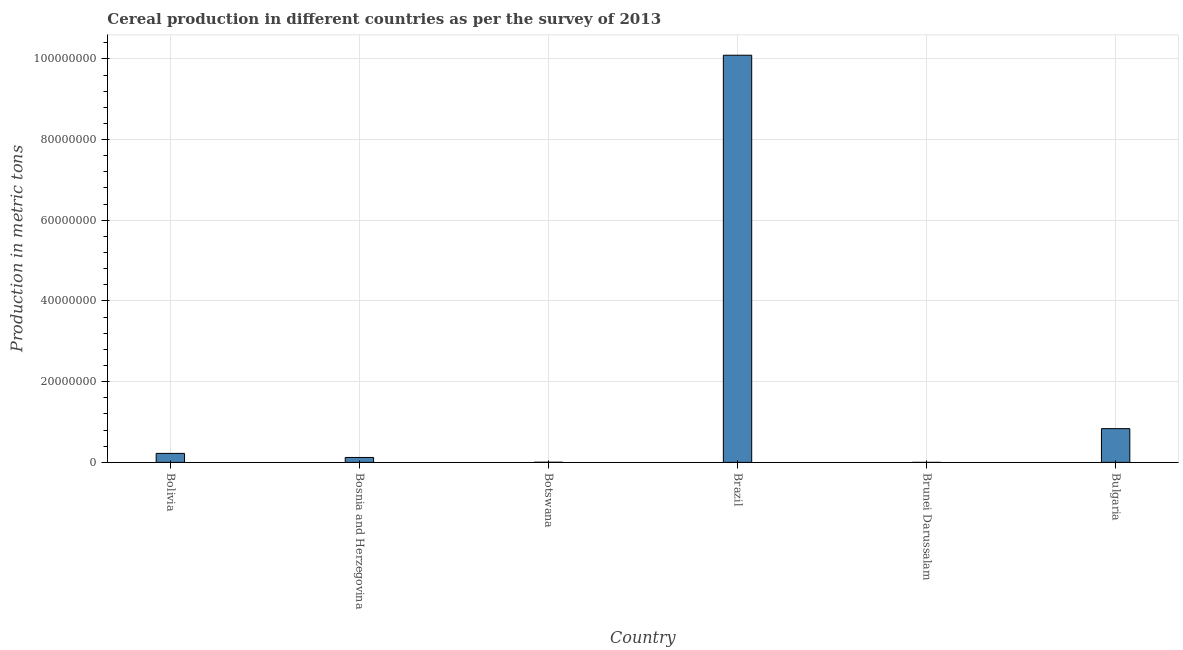Does the graph contain any zero values?
Your answer should be compact. No. What is the title of the graph?
Your answer should be very brief. Cereal production in different countries as per the survey of 2013. What is the label or title of the X-axis?
Provide a succinct answer. Country. What is the label or title of the Y-axis?
Make the answer very short. Production in metric tons. What is the cereal production in Bosnia and Herzegovina?
Make the answer very short. 1.22e+06. Across all countries, what is the maximum cereal production?
Your answer should be very brief. 1.01e+08. Across all countries, what is the minimum cereal production?
Provide a short and direct response. 1850. In which country was the cereal production minimum?
Provide a short and direct response. Brunei Darussalam. What is the sum of the cereal production?
Make the answer very short. 1.13e+08. What is the difference between the cereal production in Botswana and Brunei Darussalam?
Provide a succinct answer. 4.20e+04. What is the average cereal production per country?
Your response must be concise. 1.88e+07. What is the median cereal production?
Your answer should be very brief. 1.73e+06. What is the ratio of the cereal production in Bolivia to that in Bosnia and Herzegovina?
Offer a terse response. 1.82. Is the difference between the cereal production in Brazil and Bulgaria greater than the difference between any two countries?
Ensure brevity in your answer.  No. What is the difference between the highest and the second highest cereal production?
Give a very brief answer. 9.25e+07. Is the sum of the cereal production in Brunei Darussalam and Bulgaria greater than the maximum cereal production across all countries?
Offer a terse response. No. What is the difference between the highest and the lowest cereal production?
Make the answer very short. 1.01e+08. How many countries are there in the graph?
Give a very brief answer. 6. Are the values on the major ticks of Y-axis written in scientific E-notation?
Your response must be concise. No. What is the Production in metric tons of Bolivia?
Offer a very short reply. 2.23e+06. What is the Production in metric tons of Bosnia and Herzegovina?
Offer a terse response. 1.22e+06. What is the Production in metric tons of Botswana?
Offer a terse response. 4.38e+04. What is the Production in metric tons of Brazil?
Your answer should be compact. 1.01e+08. What is the Production in metric tons of Brunei Darussalam?
Provide a short and direct response. 1850. What is the Production in metric tons of Bulgaria?
Your answer should be compact. 8.36e+06. What is the difference between the Production in metric tons in Bolivia and Bosnia and Herzegovina?
Give a very brief answer. 1.01e+06. What is the difference between the Production in metric tons in Bolivia and Botswana?
Provide a short and direct response. 2.19e+06. What is the difference between the Production in metric tons in Bolivia and Brazil?
Ensure brevity in your answer.  -9.87e+07. What is the difference between the Production in metric tons in Bolivia and Brunei Darussalam?
Your answer should be compact. 2.23e+06. What is the difference between the Production in metric tons in Bolivia and Bulgaria?
Offer a very short reply. -6.13e+06. What is the difference between the Production in metric tons in Bosnia and Herzegovina and Botswana?
Offer a very short reply. 1.18e+06. What is the difference between the Production in metric tons in Bosnia and Herzegovina and Brazil?
Your response must be concise. -9.97e+07. What is the difference between the Production in metric tons in Bosnia and Herzegovina and Brunei Darussalam?
Provide a succinct answer. 1.22e+06. What is the difference between the Production in metric tons in Bosnia and Herzegovina and Bulgaria?
Give a very brief answer. -7.14e+06. What is the difference between the Production in metric tons in Botswana and Brazil?
Your answer should be compact. -1.01e+08. What is the difference between the Production in metric tons in Botswana and Brunei Darussalam?
Provide a short and direct response. 4.20e+04. What is the difference between the Production in metric tons in Botswana and Bulgaria?
Provide a succinct answer. -8.32e+06. What is the difference between the Production in metric tons in Brazil and Brunei Darussalam?
Your answer should be very brief. 1.01e+08. What is the difference between the Production in metric tons in Brazil and Bulgaria?
Provide a short and direct response. 9.25e+07. What is the difference between the Production in metric tons in Brunei Darussalam and Bulgaria?
Keep it short and to the point. -8.36e+06. What is the ratio of the Production in metric tons in Bolivia to that in Bosnia and Herzegovina?
Your answer should be very brief. 1.82. What is the ratio of the Production in metric tons in Bolivia to that in Botswana?
Provide a succinct answer. 50.92. What is the ratio of the Production in metric tons in Bolivia to that in Brazil?
Your answer should be very brief. 0.02. What is the ratio of the Production in metric tons in Bolivia to that in Brunei Darussalam?
Your answer should be compact. 1205.59. What is the ratio of the Production in metric tons in Bolivia to that in Bulgaria?
Your answer should be compact. 0.27. What is the ratio of the Production in metric tons in Bosnia and Herzegovina to that in Botswana?
Give a very brief answer. 27.91. What is the ratio of the Production in metric tons in Bosnia and Herzegovina to that in Brazil?
Your answer should be very brief. 0.01. What is the ratio of the Production in metric tons in Bosnia and Herzegovina to that in Brunei Darussalam?
Offer a very short reply. 660.81. What is the ratio of the Production in metric tons in Bosnia and Herzegovina to that in Bulgaria?
Give a very brief answer. 0.15. What is the ratio of the Production in metric tons in Botswana to that in Brunei Darussalam?
Your response must be concise. 23.68. What is the ratio of the Production in metric tons in Botswana to that in Bulgaria?
Keep it short and to the point. 0.01. What is the ratio of the Production in metric tons in Brazil to that in Brunei Darussalam?
Provide a short and direct response. 5.45e+04. What is the ratio of the Production in metric tons in Brazil to that in Bulgaria?
Offer a terse response. 12.06. What is the ratio of the Production in metric tons in Brunei Darussalam to that in Bulgaria?
Ensure brevity in your answer.  0. 